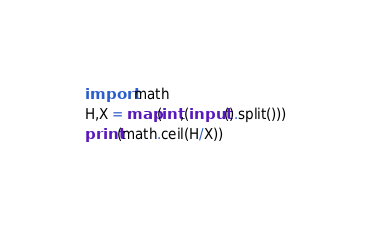<code> <loc_0><loc_0><loc_500><loc_500><_Python_>import math
H,X = map(int,(input().split()))
print(math.ceil(H/X))
</code> 